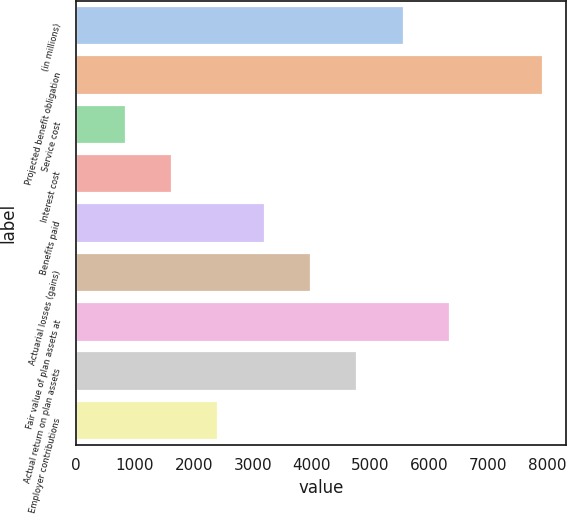Convert chart to OTSL. <chart><loc_0><loc_0><loc_500><loc_500><bar_chart><fcel>(in millions)<fcel>Projected benefit obligation<fcel>Service cost<fcel>Interest cost<fcel>Benefits paid<fcel>Actuarial losses (gains)<fcel>Fair value of plan assets at<fcel>Actual return on plan assets<fcel>Employer contributions<nl><fcel>5564.8<fcel>7924<fcel>846.4<fcel>1632.8<fcel>3205.6<fcel>3992<fcel>6351.2<fcel>4778.4<fcel>2419.2<nl></chart> 